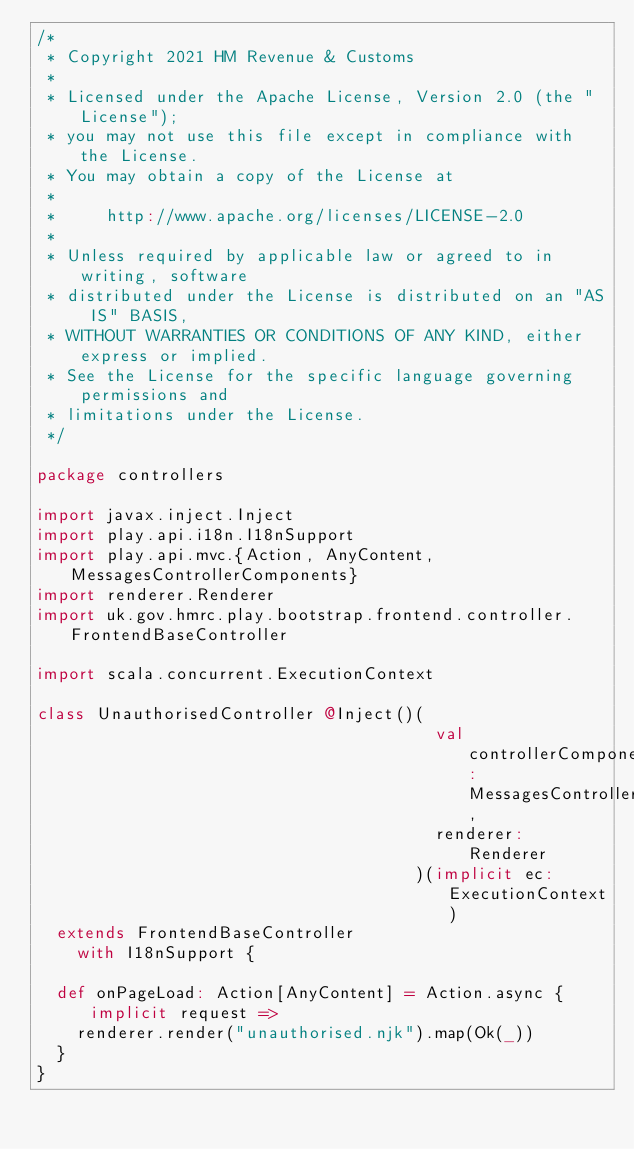Convert code to text. <code><loc_0><loc_0><loc_500><loc_500><_Scala_>/*
 * Copyright 2021 HM Revenue & Customs
 *
 * Licensed under the Apache License, Version 2.0 (the "License");
 * you may not use this file except in compliance with the License.
 * You may obtain a copy of the License at
 *
 *     http://www.apache.org/licenses/LICENSE-2.0
 *
 * Unless required by applicable law or agreed to in writing, software
 * distributed under the License is distributed on an "AS IS" BASIS,
 * WITHOUT WARRANTIES OR CONDITIONS OF ANY KIND, either express or implied.
 * See the License for the specific language governing permissions and
 * limitations under the License.
 */

package controllers

import javax.inject.Inject
import play.api.i18n.I18nSupport
import play.api.mvc.{Action, AnyContent, MessagesControllerComponents}
import renderer.Renderer
import uk.gov.hmrc.play.bootstrap.frontend.controller.FrontendBaseController

import scala.concurrent.ExecutionContext

class UnauthorisedController @Inject()(
                                        val controllerComponents: MessagesControllerComponents,
                                        renderer: Renderer
                                      )(implicit ec: ExecutionContext)
  extends FrontendBaseController
    with I18nSupport {

  def onPageLoad: Action[AnyContent] = Action.async { implicit request =>
    renderer.render("unauthorised.njk").map(Ok(_))
  }
}
</code> 